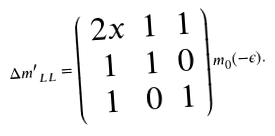Convert formula to latex. <formula><loc_0><loc_0><loc_500><loc_500>\Delta { m ^ { \prime } } _ { L L } = \left ( \begin{array} { c c c } 2 x & 1 & 1 \\ 1 & 1 & 0 \\ 1 & 0 & 1 \end{array} \right ) m _ { 0 } ( - \epsilon ) .</formula> 